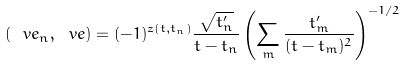<formula> <loc_0><loc_0><loc_500><loc_500>\left ( { \ v e _ { n } } , \ v e \right ) = ( - 1 ) ^ { z ( t , t _ { n } ) } \frac { \sqrt { t _ { n } ^ { \prime } } } { t - t _ { n } } \left ( \sum _ { m } \frac { t _ { m } ^ { \prime } } { ( t - t _ { m } ) ^ { 2 } } \right ) ^ { - 1 / 2 }</formula> 